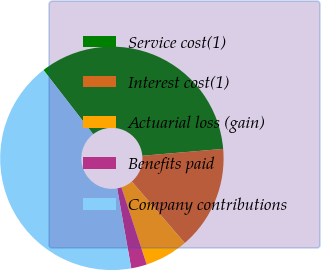<chart> <loc_0><loc_0><loc_500><loc_500><pie_chart><fcel>Service cost(1)<fcel>Interest cost(1)<fcel>Actuarial loss (gain)<fcel>Benefits paid<fcel>Company contributions<nl><fcel>34.14%<fcel>15.03%<fcel>6.27%<fcel>2.27%<fcel>42.28%<nl></chart> 